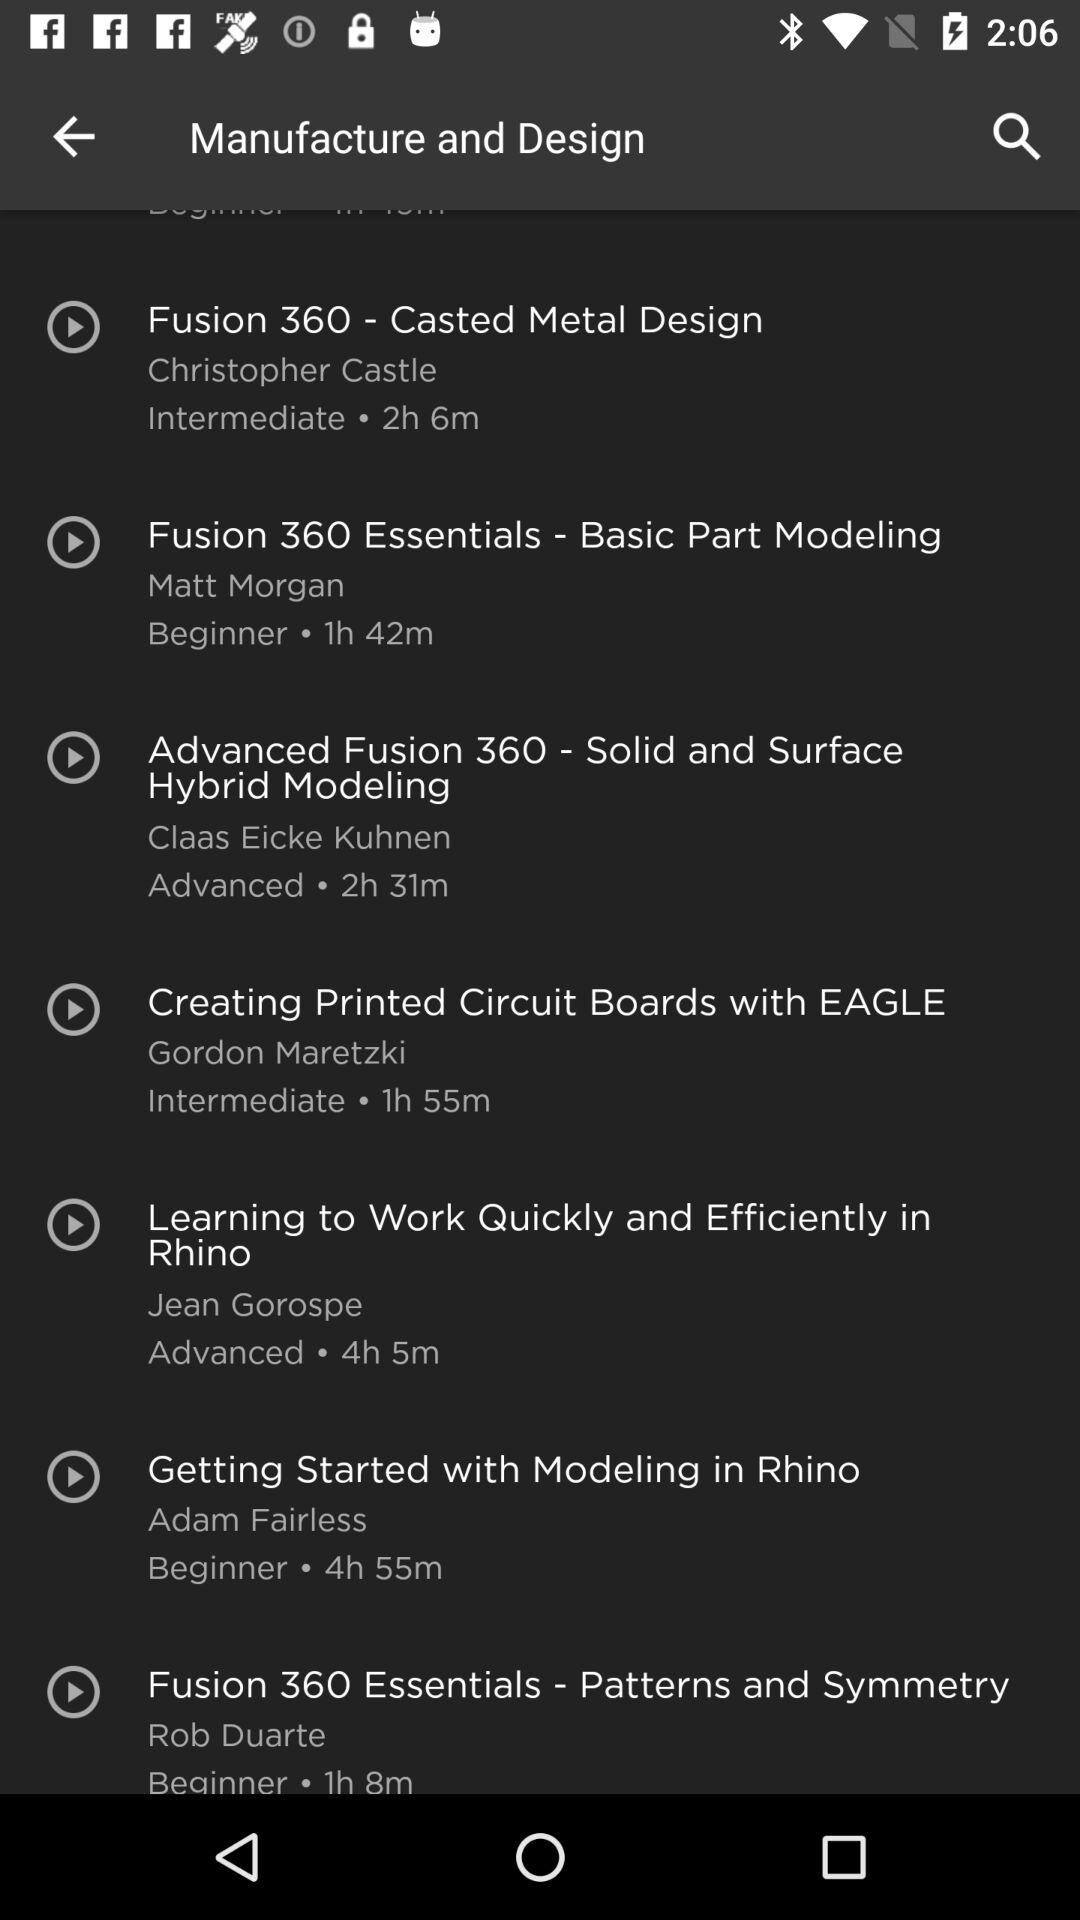What is the time duration of the course "Fusion 360 - Casted Metal Design"? The time duration of the course "Fusion 360 - Casted Metal Design" is 2 hours 6 minutes. 